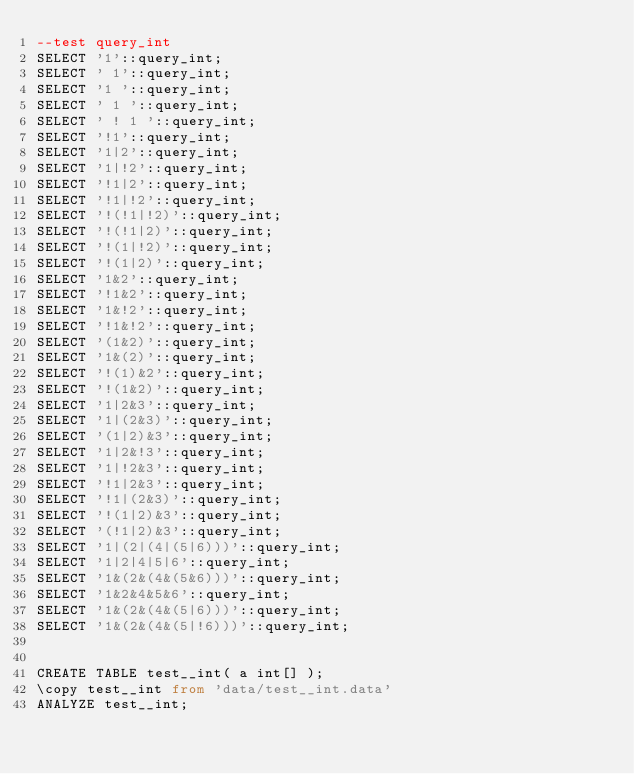<code> <loc_0><loc_0><loc_500><loc_500><_SQL_>--test query_int
SELECT '1'::query_int;
SELECT ' 1'::query_int;
SELECT '1 '::query_int;
SELECT ' 1 '::query_int;
SELECT ' ! 1 '::query_int;
SELECT '!1'::query_int;
SELECT '1|2'::query_int;
SELECT '1|!2'::query_int;
SELECT '!1|2'::query_int;
SELECT '!1|!2'::query_int;
SELECT '!(!1|!2)'::query_int;
SELECT '!(!1|2)'::query_int;
SELECT '!(1|!2)'::query_int;
SELECT '!(1|2)'::query_int;
SELECT '1&2'::query_int;
SELECT '!1&2'::query_int;
SELECT '1&!2'::query_int;
SELECT '!1&!2'::query_int;
SELECT '(1&2)'::query_int;
SELECT '1&(2)'::query_int;
SELECT '!(1)&2'::query_int;
SELECT '!(1&2)'::query_int;
SELECT '1|2&3'::query_int;
SELECT '1|(2&3)'::query_int;
SELECT '(1|2)&3'::query_int;
SELECT '1|2&!3'::query_int;
SELECT '1|!2&3'::query_int;
SELECT '!1|2&3'::query_int;
SELECT '!1|(2&3)'::query_int;
SELECT '!(1|2)&3'::query_int;
SELECT '(!1|2)&3'::query_int;
SELECT '1|(2|(4|(5|6)))'::query_int;
SELECT '1|2|4|5|6'::query_int;
SELECT '1&(2&(4&(5&6)))'::query_int;
SELECT '1&2&4&5&6'::query_int;
SELECT '1&(2&(4&(5|6)))'::query_int;
SELECT '1&(2&(4&(5|!6)))'::query_int;


CREATE TABLE test__int( a int[] );
\copy test__int from 'data/test__int.data'
ANALYZE test__int;
</code> 